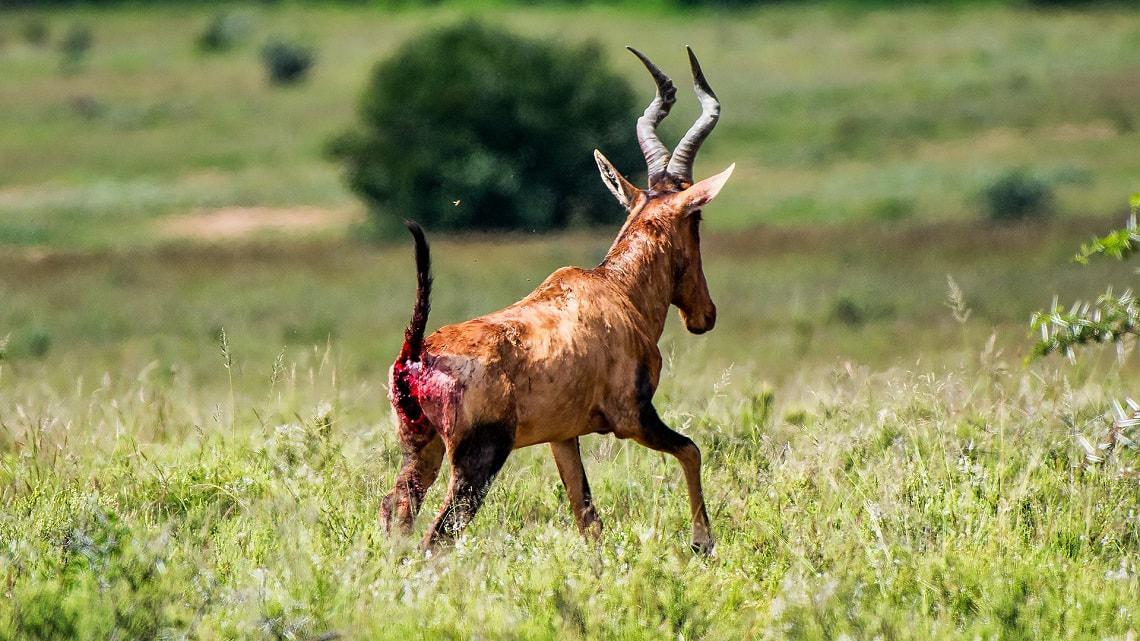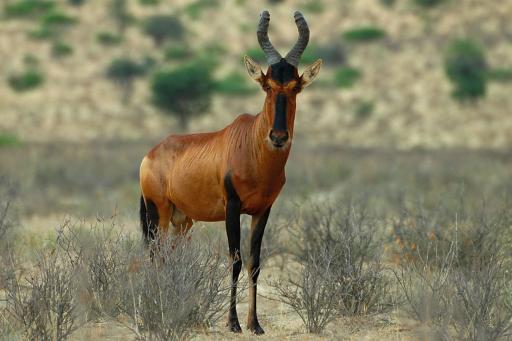The first image is the image on the left, the second image is the image on the right. Analyze the images presented: Is the assertion "The left and right image contains the same number of elk." valid? Answer yes or no. Yes. The first image is the image on the left, the second image is the image on the right. For the images shown, is this caption "One image contains one horned animal standing with its body aimed rightward and its face turned forwards, and the other image includes a horned animal with its rear to the camera." true? Answer yes or no. Yes. 